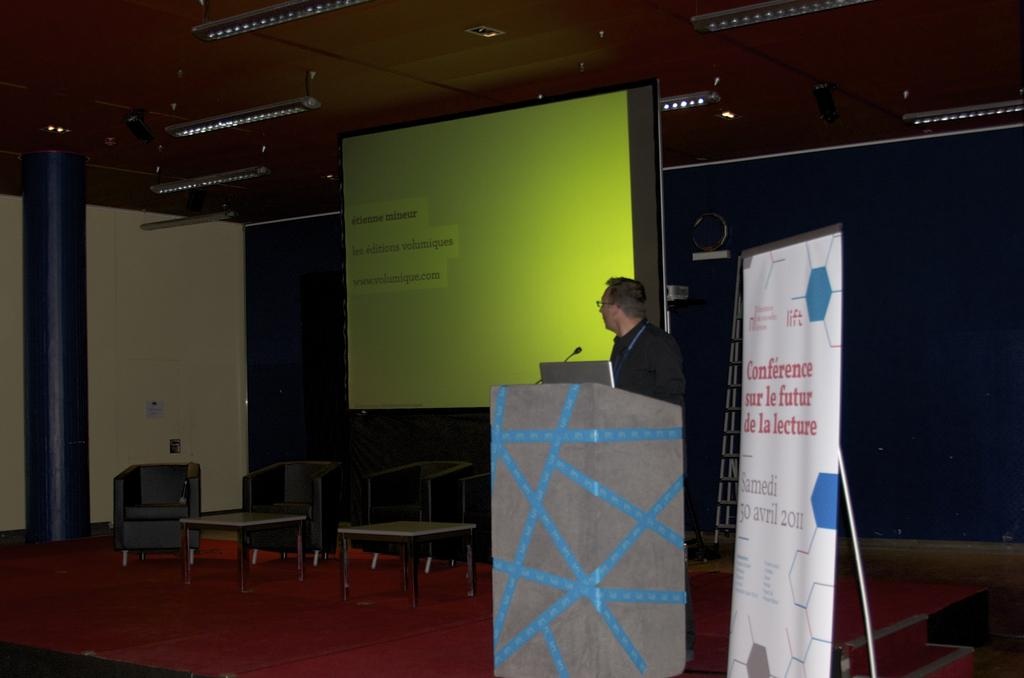What type of furniture is present in the image? There is a chair and a table in the image. What is the man in the image doing? The man is standing in front of a podium. What equipment is visible in the image? There is a microphone and a laptop in the image. What is located at the back side of the image? There is a screen at the back side of the image. Can you tell me how many volcanoes are visible in the image? There are no volcanoes present in the image. What is the man's daughter doing in the image? There is no mention of a daughter in the image, and the man's actions are focused on standing in front of a podium. 